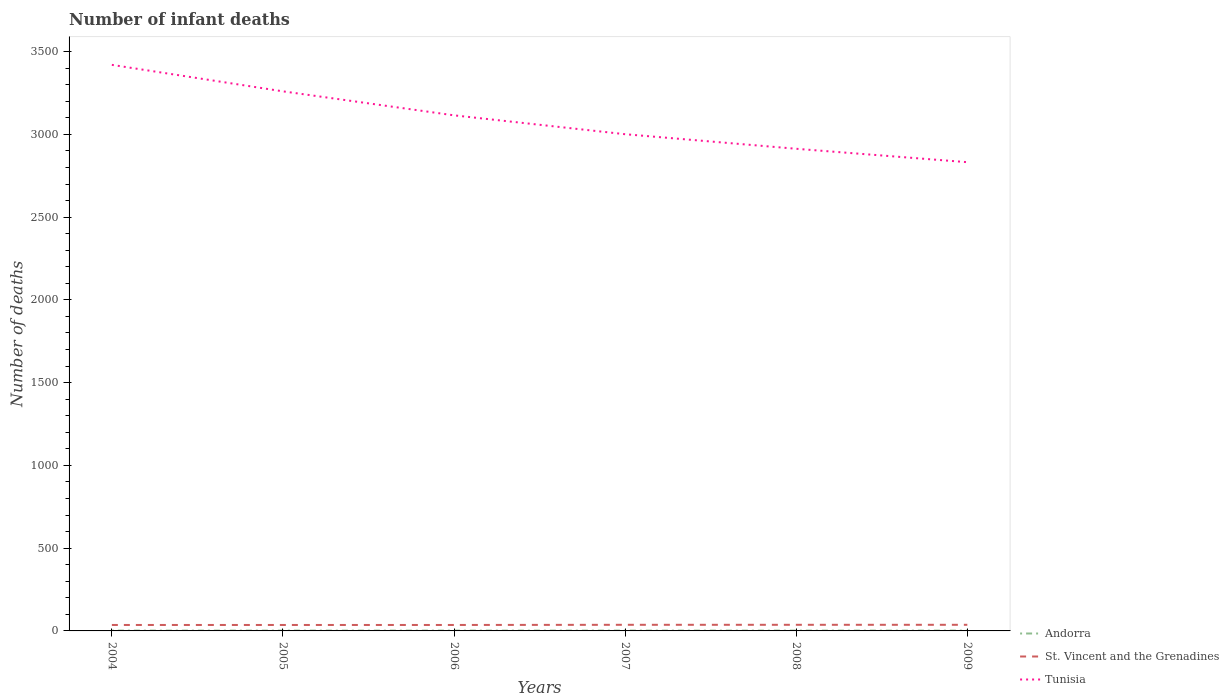Is the number of lines equal to the number of legend labels?
Ensure brevity in your answer.  Yes. In which year was the number of infant deaths in Tunisia maximum?
Give a very brief answer. 2009. Is the number of infant deaths in Tunisia strictly greater than the number of infant deaths in Andorra over the years?
Keep it short and to the point. No. How many lines are there?
Give a very brief answer. 3. What is the difference between two consecutive major ticks on the Y-axis?
Provide a succinct answer. 500. What is the title of the graph?
Ensure brevity in your answer.  Number of infant deaths. Does "Malaysia" appear as one of the legend labels in the graph?
Your response must be concise. No. What is the label or title of the X-axis?
Your answer should be very brief. Years. What is the label or title of the Y-axis?
Give a very brief answer. Number of deaths. What is the Number of deaths of St. Vincent and the Grenadines in 2004?
Make the answer very short. 36. What is the Number of deaths in Tunisia in 2004?
Ensure brevity in your answer.  3420. What is the Number of deaths of Tunisia in 2005?
Ensure brevity in your answer.  3260. What is the Number of deaths of Tunisia in 2006?
Keep it short and to the point. 3115. What is the Number of deaths of Andorra in 2007?
Make the answer very short. 2. What is the Number of deaths in St. Vincent and the Grenadines in 2007?
Ensure brevity in your answer.  37. What is the Number of deaths of Tunisia in 2007?
Provide a short and direct response. 3001. What is the Number of deaths of Tunisia in 2008?
Offer a terse response. 2913. What is the Number of deaths of Tunisia in 2009?
Your response must be concise. 2832. Across all years, what is the maximum Number of deaths of Tunisia?
Offer a very short reply. 3420. Across all years, what is the minimum Number of deaths in Andorra?
Offer a very short reply. 2. Across all years, what is the minimum Number of deaths in St. Vincent and the Grenadines?
Provide a succinct answer. 36. Across all years, what is the minimum Number of deaths in Tunisia?
Your answer should be compact. 2832. What is the total Number of deaths in St. Vincent and the Grenadines in the graph?
Your answer should be compact. 219. What is the total Number of deaths in Tunisia in the graph?
Your answer should be very brief. 1.85e+04. What is the difference between the Number of deaths of Andorra in 2004 and that in 2005?
Offer a terse response. 0. What is the difference between the Number of deaths in St. Vincent and the Grenadines in 2004 and that in 2005?
Offer a very short reply. 0. What is the difference between the Number of deaths of Tunisia in 2004 and that in 2005?
Offer a very short reply. 160. What is the difference between the Number of deaths of Andorra in 2004 and that in 2006?
Make the answer very short. 0. What is the difference between the Number of deaths in St. Vincent and the Grenadines in 2004 and that in 2006?
Provide a short and direct response. 0. What is the difference between the Number of deaths in Tunisia in 2004 and that in 2006?
Offer a terse response. 305. What is the difference between the Number of deaths in Tunisia in 2004 and that in 2007?
Offer a very short reply. 419. What is the difference between the Number of deaths in Andorra in 2004 and that in 2008?
Your answer should be compact. 0. What is the difference between the Number of deaths of St. Vincent and the Grenadines in 2004 and that in 2008?
Ensure brevity in your answer.  -1. What is the difference between the Number of deaths of Tunisia in 2004 and that in 2008?
Provide a short and direct response. 507. What is the difference between the Number of deaths of St. Vincent and the Grenadines in 2004 and that in 2009?
Keep it short and to the point. -1. What is the difference between the Number of deaths in Tunisia in 2004 and that in 2009?
Keep it short and to the point. 588. What is the difference between the Number of deaths in Andorra in 2005 and that in 2006?
Your response must be concise. 0. What is the difference between the Number of deaths in Tunisia in 2005 and that in 2006?
Offer a very short reply. 145. What is the difference between the Number of deaths of Tunisia in 2005 and that in 2007?
Your answer should be very brief. 259. What is the difference between the Number of deaths in Tunisia in 2005 and that in 2008?
Keep it short and to the point. 347. What is the difference between the Number of deaths of Andorra in 2005 and that in 2009?
Your response must be concise. 0. What is the difference between the Number of deaths in St. Vincent and the Grenadines in 2005 and that in 2009?
Your response must be concise. -1. What is the difference between the Number of deaths in Tunisia in 2005 and that in 2009?
Offer a terse response. 428. What is the difference between the Number of deaths in Andorra in 2006 and that in 2007?
Keep it short and to the point. 0. What is the difference between the Number of deaths in St. Vincent and the Grenadines in 2006 and that in 2007?
Keep it short and to the point. -1. What is the difference between the Number of deaths in Tunisia in 2006 and that in 2007?
Give a very brief answer. 114. What is the difference between the Number of deaths in Andorra in 2006 and that in 2008?
Make the answer very short. 0. What is the difference between the Number of deaths in St. Vincent and the Grenadines in 2006 and that in 2008?
Provide a short and direct response. -1. What is the difference between the Number of deaths in Tunisia in 2006 and that in 2008?
Make the answer very short. 202. What is the difference between the Number of deaths of St. Vincent and the Grenadines in 2006 and that in 2009?
Provide a short and direct response. -1. What is the difference between the Number of deaths of Tunisia in 2006 and that in 2009?
Make the answer very short. 283. What is the difference between the Number of deaths in Andorra in 2007 and that in 2009?
Offer a terse response. 0. What is the difference between the Number of deaths of Tunisia in 2007 and that in 2009?
Give a very brief answer. 169. What is the difference between the Number of deaths of Andorra in 2008 and that in 2009?
Offer a very short reply. 0. What is the difference between the Number of deaths of St. Vincent and the Grenadines in 2008 and that in 2009?
Offer a terse response. 0. What is the difference between the Number of deaths in Tunisia in 2008 and that in 2009?
Make the answer very short. 81. What is the difference between the Number of deaths in Andorra in 2004 and the Number of deaths in St. Vincent and the Grenadines in 2005?
Make the answer very short. -34. What is the difference between the Number of deaths of Andorra in 2004 and the Number of deaths of Tunisia in 2005?
Provide a short and direct response. -3258. What is the difference between the Number of deaths in St. Vincent and the Grenadines in 2004 and the Number of deaths in Tunisia in 2005?
Provide a short and direct response. -3224. What is the difference between the Number of deaths of Andorra in 2004 and the Number of deaths of St. Vincent and the Grenadines in 2006?
Make the answer very short. -34. What is the difference between the Number of deaths of Andorra in 2004 and the Number of deaths of Tunisia in 2006?
Ensure brevity in your answer.  -3113. What is the difference between the Number of deaths of St. Vincent and the Grenadines in 2004 and the Number of deaths of Tunisia in 2006?
Offer a terse response. -3079. What is the difference between the Number of deaths of Andorra in 2004 and the Number of deaths of St. Vincent and the Grenadines in 2007?
Provide a short and direct response. -35. What is the difference between the Number of deaths of Andorra in 2004 and the Number of deaths of Tunisia in 2007?
Provide a short and direct response. -2999. What is the difference between the Number of deaths of St. Vincent and the Grenadines in 2004 and the Number of deaths of Tunisia in 2007?
Keep it short and to the point. -2965. What is the difference between the Number of deaths in Andorra in 2004 and the Number of deaths in St. Vincent and the Grenadines in 2008?
Ensure brevity in your answer.  -35. What is the difference between the Number of deaths of Andorra in 2004 and the Number of deaths of Tunisia in 2008?
Make the answer very short. -2911. What is the difference between the Number of deaths in St. Vincent and the Grenadines in 2004 and the Number of deaths in Tunisia in 2008?
Your answer should be very brief. -2877. What is the difference between the Number of deaths of Andorra in 2004 and the Number of deaths of St. Vincent and the Grenadines in 2009?
Provide a succinct answer. -35. What is the difference between the Number of deaths in Andorra in 2004 and the Number of deaths in Tunisia in 2009?
Offer a terse response. -2830. What is the difference between the Number of deaths of St. Vincent and the Grenadines in 2004 and the Number of deaths of Tunisia in 2009?
Make the answer very short. -2796. What is the difference between the Number of deaths of Andorra in 2005 and the Number of deaths of St. Vincent and the Grenadines in 2006?
Ensure brevity in your answer.  -34. What is the difference between the Number of deaths in Andorra in 2005 and the Number of deaths in Tunisia in 2006?
Give a very brief answer. -3113. What is the difference between the Number of deaths of St. Vincent and the Grenadines in 2005 and the Number of deaths of Tunisia in 2006?
Make the answer very short. -3079. What is the difference between the Number of deaths of Andorra in 2005 and the Number of deaths of St. Vincent and the Grenadines in 2007?
Give a very brief answer. -35. What is the difference between the Number of deaths in Andorra in 2005 and the Number of deaths in Tunisia in 2007?
Make the answer very short. -2999. What is the difference between the Number of deaths of St. Vincent and the Grenadines in 2005 and the Number of deaths of Tunisia in 2007?
Provide a succinct answer. -2965. What is the difference between the Number of deaths in Andorra in 2005 and the Number of deaths in St. Vincent and the Grenadines in 2008?
Your answer should be compact. -35. What is the difference between the Number of deaths of Andorra in 2005 and the Number of deaths of Tunisia in 2008?
Keep it short and to the point. -2911. What is the difference between the Number of deaths in St. Vincent and the Grenadines in 2005 and the Number of deaths in Tunisia in 2008?
Your answer should be compact. -2877. What is the difference between the Number of deaths in Andorra in 2005 and the Number of deaths in St. Vincent and the Grenadines in 2009?
Your answer should be very brief. -35. What is the difference between the Number of deaths in Andorra in 2005 and the Number of deaths in Tunisia in 2009?
Ensure brevity in your answer.  -2830. What is the difference between the Number of deaths in St. Vincent and the Grenadines in 2005 and the Number of deaths in Tunisia in 2009?
Ensure brevity in your answer.  -2796. What is the difference between the Number of deaths of Andorra in 2006 and the Number of deaths of St. Vincent and the Grenadines in 2007?
Your answer should be very brief. -35. What is the difference between the Number of deaths in Andorra in 2006 and the Number of deaths in Tunisia in 2007?
Provide a short and direct response. -2999. What is the difference between the Number of deaths of St. Vincent and the Grenadines in 2006 and the Number of deaths of Tunisia in 2007?
Your answer should be very brief. -2965. What is the difference between the Number of deaths of Andorra in 2006 and the Number of deaths of St. Vincent and the Grenadines in 2008?
Provide a short and direct response. -35. What is the difference between the Number of deaths in Andorra in 2006 and the Number of deaths in Tunisia in 2008?
Offer a very short reply. -2911. What is the difference between the Number of deaths in St. Vincent and the Grenadines in 2006 and the Number of deaths in Tunisia in 2008?
Keep it short and to the point. -2877. What is the difference between the Number of deaths of Andorra in 2006 and the Number of deaths of St. Vincent and the Grenadines in 2009?
Your response must be concise. -35. What is the difference between the Number of deaths in Andorra in 2006 and the Number of deaths in Tunisia in 2009?
Provide a succinct answer. -2830. What is the difference between the Number of deaths in St. Vincent and the Grenadines in 2006 and the Number of deaths in Tunisia in 2009?
Your answer should be very brief. -2796. What is the difference between the Number of deaths of Andorra in 2007 and the Number of deaths of St. Vincent and the Grenadines in 2008?
Your answer should be compact. -35. What is the difference between the Number of deaths of Andorra in 2007 and the Number of deaths of Tunisia in 2008?
Give a very brief answer. -2911. What is the difference between the Number of deaths in St. Vincent and the Grenadines in 2007 and the Number of deaths in Tunisia in 2008?
Keep it short and to the point. -2876. What is the difference between the Number of deaths in Andorra in 2007 and the Number of deaths in St. Vincent and the Grenadines in 2009?
Provide a short and direct response. -35. What is the difference between the Number of deaths in Andorra in 2007 and the Number of deaths in Tunisia in 2009?
Ensure brevity in your answer.  -2830. What is the difference between the Number of deaths in St. Vincent and the Grenadines in 2007 and the Number of deaths in Tunisia in 2009?
Ensure brevity in your answer.  -2795. What is the difference between the Number of deaths in Andorra in 2008 and the Number of deaths in St. Vincent and the Grenadines in 2009?
Ensure brevity in your answer.  -35. What is the difference between the Number of deaths of Andorra in 2008 and the Number of deaths of Tunisia in 2009?
Give a very brief answer. -2830. What is the difference between the Number of deaths in St. Vincent and the Grenadines in 2008 and the Number of deaths in Tunisia in 2009?
Your answer should be very brief. -2795. What is the average Number of deaths in St. Vincent and the Grenadines per year?
Your response must be concise. 36.5. What is the average Number of deaths of Tunisia per year?
Provide a succinct answer. 3090.17. In the year 2004, what is the difference between the Number of deaths of Andorra and Number of deaths of St. Vincent and the Grenadines?
Your answer should be compact. -34. In the year 2004, what is the difference between the Number of deaths in Andorra and Number of deaths in Tunisia?
Your response must be concise. -3418. In the year 2004, what is the difference between the Number of deaths of St. Vincent and the Grenadines and Number of deaths of Tunisia?
Keep it short and to the point. -3384. In the year 2005, what is the difference between the Number of deaths of Andorra and Number of deaths of St. Vincent and the Grenadines?
Provide a succinct answer. -34. In the year 2005, what is the difference between the Number of deaths of Andorra and Number of deaths of Tunisia?
Your answer should be compact. -3258. In the year 2005, what is the difference between the Number of deaths in St. Vincent and the Grenadines and Number of deaths in Tunisia?
Provide a short and direct response. -3224. In the year 2006, what is the difference between the Number of deaths of Andorra and Number of deaths of St. Vincent and the Grenadines?
Ensure brevity in your answer.  -34. In the year 2006, what is the difference between the Number of deaths in Andorra and Number of deaths in Tunisia?
Your response must be concise. -3113. In the year 2006, what is the difference between the Number of deaths in St. Vincent and the Grenadines and Number of deaths in Tunisia?
Give a very brief answer. -3079. In the year 2007, what is the difference between the Number of deaths in Andorra and Number of deaths in St. Vincent and the Grenadines?
Your answer should be compact. -35. In the year 2007, what is the difference between the Number of deaths of Andorra and Number of deaths of Tunisia?
Keep it short and to the point. -2999. In the year 2007, what is the difference between the Number of deaths in St. Vincent and the Grenadines and Number of deaths in Tunisia?
Give a very brief answer. -2964. In the year 2008, what is the difference between the Number of deaths of Andorra and Number of deaths of St. Vincent and the Grenadines?
Provide a succinct answer. -35. In the year 2008, what is the difference between the Number of deaths of Andorra and Number of deaths of Tunisia?
Give a very brief answer. -2911. In the year 2008, what is the difference between the Number of deaths of St. Vincent and the Grenadines and Number of deaths of Tunisia?
Give a very brief answer. -2876. In the year 2009, what is the difference between the Number of deaths of Andorra and Number of deaths of St. Vincent and the Grenadines?
Your answer should be very brief. -35. In the year 2009, what is the difference between the Number of deaths of Andorra and Number of deaths of Tunisia?
Provide a succinct answer. -2830. In the year 2009, what is the difference between the Number of deaths of St. Vincent and the Grenadines and Number of deaths of Tunisia?
Your response must be concise. -2795. What is the ratio of the Number of deaths of Andorra in 2004 to that in 2005?
Provide a short and direct response. 1. What is the ratio of the Number of deaths in St. Vincent and the Grenadines in 2004 to that in 2005?
Give a very brief answer. 1. What is the ratio of the Number of deaths in Tunisia in 2004 to that in 2005?
Your response must be concise. 1.05. What is the ratio of the Number of deaths of St. Vincent and the Grenadines in 2004 to that in 2006?
Make the answer very short. 1. What is the ratio of the Number of deaths of Tunisia in 2004 to that in 2006?
Keep it short and to the point. 1.1. What is the ratio of the Number of deaths in Andorra in 2004 to that in 2007?
Give a very brief answer. 1. What is the ratio of the Number of deaths in St. Vincent and the Grenadines in 2004 to that in 2007?
Your response must be concise. 0.97. What is the ratio of the Number of deaths in Tunisia in 2004 to that in 2007?
Ensure brevity in your answer.  1.14. What is the ratio of the Number of deaths in Andorra in 2004 to that in 2008?
Give a very brief answer. 1. What is the ratio of the Number of deaths of St. Vincent and the Grenadines in 2004 to that in 2008?
Provide a succinct answer. 0.97. What is the ratio of the Number of deaths in Tunisia in 2004 to that in 2008?
Your answer should be compact. 1.17. What is the ratio of the Number of deaths of Tunisia in 2004 to that in 2009?
Offer a very short reply. 1.21. What is the ratio of the Number of deaths of St. Vincent and the Grenadines in 2005 to that in 2006?
Keep it short and to the point. 1. What is the ratio of the Number of deaths of Tunisia in 2005 to that in 2006?
Provide a short and direct response. 1.05. What is the ratio of the Number of deaths of Andorra in 2005 to that in 2007?
Your answer should be very brief. 1. What is the ratio of the Number of deaths of St. Vincent and the Grenadines in 2005 to that in 2007?
Ensure brevity in your answer.  0.97. What is the ratio of the Number of deaths in Tunisia in 2005 to that in 2007?
Provide a short and direct response. 1.09. What is the ratio of the Number of deaths of Andorra in 2005 to that in 2008?
Make the answer very short. 1. What is the ratio of the Number of deaths in St. Vincent and the Grenadines in 2005 to that in 2008?
Ensure brevity in your answer.  0.97. What is the ratio of the Number of deaths in Tunisia in 2005 to that in 2008?
Provide a short and direct response. 1.12. What is the ratio of the Number of deaths in Andorra in 2005 to that in 2009?
Provide a succinct answer. 1. What is the ratio of the Number of deaths of Tunisia in 2005 to that in 2009?
Your response must be concise. 1.15. What is the ratio of the Number of deaths in St. Vincent and the Grenadines in 2006 to that in 2007?
Make the answer very short. 0.97. What is the ratio of the Number of deaths in Tunisia in 2006 to that in 2007?
Make the answer very short. 1.04. What is the ratio of the Number of deaths in Andorra in 2006 to that in 2008?
Your answer should be very brief. 1. What is the ratio of the Number of deaths in St. Vincent and the Grenadines in 2006 to that in 2008?
Ensure brevity in your answer.  0.97. What is the ratio of the Number of deaths in Tunisia in 2006 to that in 2008?
Your answer should be compact. 1.07. What is the ratio of the Number of deaths of Andorra in 2006 to that in 2009?
Provide a succinct answer. 1. What is the ratio of the Number of deaths in Tunisia in 2006 to that in 2009?
Keep it short and to the point. 1.1. What is the ratio of the Number of deaths of Andorra in 2007 to that in 2008?
Your response must be concise. 1. What is the ratio of the Number of deaths in St. Vincent and the Grenadines in 2007 to that in 2008?
Provide a short and direct response. 1. What is the ratio of the Number of deaths in Tunisia in 2007 to that in 2008?
Provide a short and direct response. 1.03. What is the ratio of the Number of deaths in Andorra in 2007 to that in 2009?
Provide a succinct answer. 1. What is the ratio of the Number of deaths of St. Vincent and the Grenadines in 2007 to that in 2009?
Your answer should be compact. 1. What is the ratio of the Number of deaths in Tunisia in 2007 to that in 2009?
Make the answer very short. 1.06. What is the ratio of the Number of deaths of St. Vincent and the Grenadines in 2008 to that in 2009?
Provide a short and direct response. 1. What is the ratio of the Number of deaths in Tunisia in 2008 to that in 2009?
Give a very brief answer. 1.03. What is the difference between the highest and the second highest Number of deaths in Andorra?
Offer a very short reply. 0. What is the difference between the highest and the second highest Number of deaths of Tunisia?
Your answer should be very brief. 160. What is the difference between the highest and the lowest Number of deaths of Tunisia?
Keep it short and to the point. 588. 